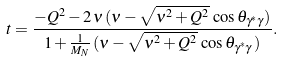Convert formula to latex. <formula><loc_0><loc_0><loc_500><loc_500>t = \frac { - Q ^ { 2 } - 2 \, \nu \, ( \nu - \sqrt { \nu ^ { 2 } + Q ^ { 2 } } \, \cos \theta _ { \gamma ^ { * } \gamma } ) } { 1 + \frac { 1 } { M _ { N } } \, ( \nu - \sqrt { \nu ^ { 2 } + Q ^ { 2 } } \, \cos \theta _ { \gamma ^ { * } \gamma } \, ) } .</formula> 